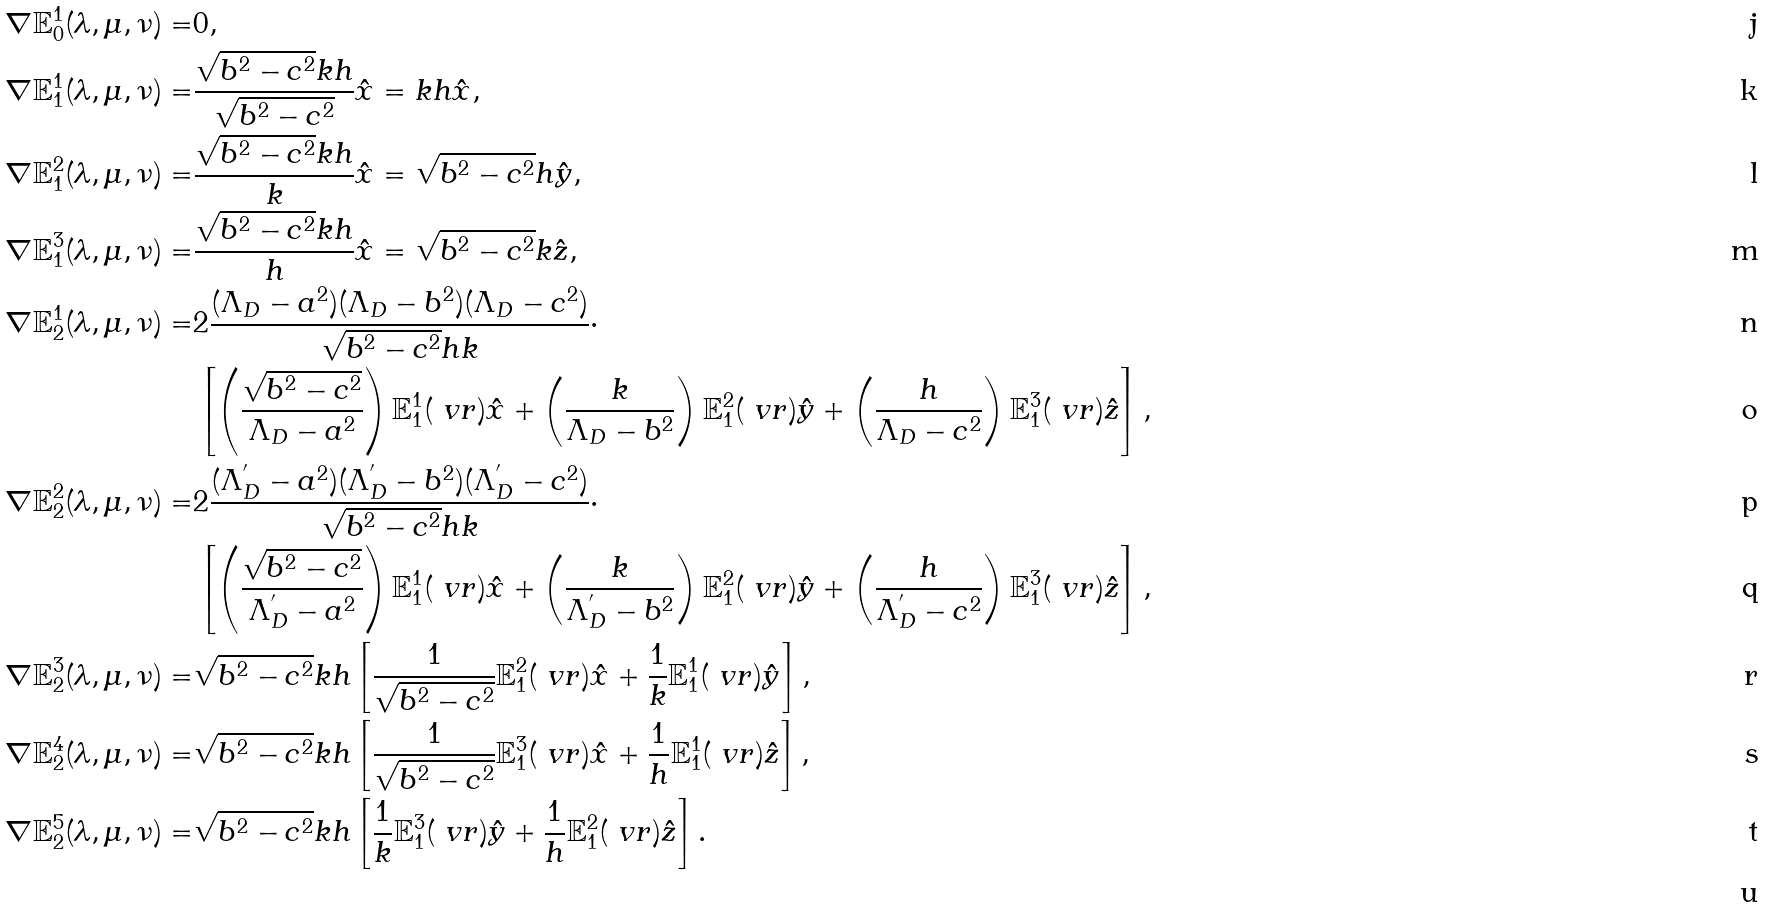<formula> <loc_0><loc_0><loc_500><loc_500>\nabla \mathbb { E } _ { 0 } ^ { 1 } ( \lambda , \mu , \nu ) = & 0 , \\ \nabla \mathbb { E } _ { 1 } ^ { 1 } ( \lambda , \mu , \nu ) = & \frac { \sqrt { b ^ { 2 } - c ^ { 2 } } k h } { \sqrt { b ^ { 2 } - c ^ { 2 } } } \hat { x } = k h \hat { x } , \\ \nabla \mathbb { E } _ { 1 } ^ { 2 } ( \lambda , \mu , \nu ) = & \frac { \sqrt { b ^ { 2 } - c ^ { 2 } } k h } { k } \hat { x } = \sqrt { b ^ { 2 } - c ^ { 2 } } h \hat { y } , \\ \nabla \mathbb { E } _ { 1 } ^ { 3 } ( \lambda , \mu , \nu ) = & \frac { \sqrt { b ^ { 2 } - c ^ { 2 } } k h } { h } \hat { x } = \sqrt { b ^ { 2 } - c ^ { 2 } } k \hat { z } , \\ \nabla \mathbb { E } _ { 2 } ^ { 1 } ( \lambda , \mu , \nu ) = & 2 \frac { ( \Lambda _ { D } - a ^ { 2 } ) ( \Lambda _ { D } - b ^ { 2 } ) ( \Lambda _ { D } - c ^ { 2 } ) } { \sqrt { b ^ { 2 } - c ^ { 2 } } h k } \cdot \\ & \left [ \left ( \frac { \sqrt { b ^ { 2 } - c ^ { 2 } } } { \Lambda _ { D } - a ^ { 2 } } \right ) \mathbb { E } _ { 1 } ^ { 1 } ( \ v r ) \hat { x } + \left ( \frac { k } { \Lambda _ { D } - b ^ { 2 } } \right ) \mathbb { E } _ { 1 } ^ { 2 } ( \ v r ) \hat { y } + \left ( \frac { h } { \Lambda _ { D } - c ^ { 2 } } \right ) \mathbb { E } _ { 1 } ^ { 3 } ( \ v r ) \hat { z } \right ] , \\ \nabla \mathbb { E } _ { 2 } ^ { 2 } ( \lambda , \mu , \nu ) = & 2 \frac { ( \Lambda _ { D } ^ { ^ { \prime } } - a ^ { 2 } ) ( \Lambda _ { D } ^ { ^ { \prime } } - b ^ { 2 } ) ( \Lambda _ { D } ^ { ^ { \prime } } - c ^ { 2 } ) } { \sqrt { b ^ { 2 } - c ^ { 2 } } h k } \cdot \\ & \left [ \left ( \frac { \sqrt { b ^ { 2 } - c ^ { 2 } } } { \Lambda _ { D } ^ { ^ { \prime } } - a ^ { 2 } } \right ) \mathbb { E } _ { 1 } ^ { 1 } ( \ v r ) \hat { x } + \left ( \frac { k } { \Lambda _ { D } ^ { ^ { \prime } } - b ^ { 2 } } \right ) \mathbb { E } _ { 1 } ^ { 2 } ( \ v r ) \hat { y } + \left ( \frac { h } { \Lambda _ { D } ^ { ^ { \prime } } - c ^ { 2 } } \right ) \mathbb { E } _ { 1 } ^ { 3 } ( \ v r ) \hat { z } \right ] , \\ \nabla \mathbb { E } _ { 2 } ^ { 3 } ( \lambda , \mu , \nu ) = & \sqrt { b ^ { 2 } - c ^ { 2 } } k h \left [ \frac { 1 } { \sqrt { b ^ { 2 } - c ^ { 2 } } } \mathbb { E } _ { 1 } ^ { 2 } ( \ v r ) \hat { x } + \frac { 1 } { k } \mathbb { E } _ { 1 } ^ { 1 } ( \ v r ) \hat { y } \right ] , \\ \nabla \mathbb { E } _ { 2 } ^ { 4 } ( \lambda , \mu , \nu ) = & \sqrt { b ^ { 2 } - c ^ { 2 } } k h \left [ \frac { 1 } { \sqrt { b ^ { 2 } - c ^ { 2 } } } \mathbb { E } _ { 1 } ^ { 3 } ( \ v r ) \hat { x } + \frac { 1 } { h } \mathbb { E } _ { 1 } ^ { 1 } ( \ v r ) \hat { z } \right ] , \\ \nabla \mathbb { E } _ { 2 } ^ { 5 } ( \lambda , \mu , \nu ) = & \sqrt { b ^ { 2 } - c ^ { 2 } } k h \left [ \frac { 1 } { k } \mathbb { E } _ { 1 } ^ { 3 } ( \ v r ) \hat { y } + \frac { 1 } { h } \mathbb { E } _ { 1 } ^ { 2 } ( \ v r ) \hat { z } \right ] . \\</formula> 